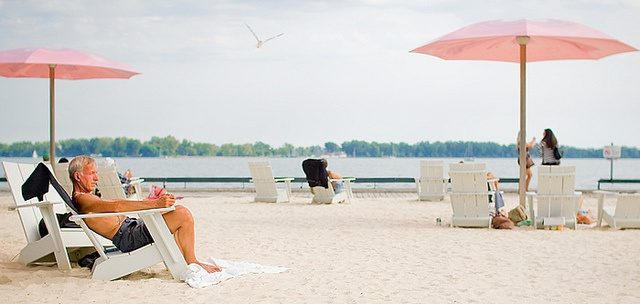Describe the objects in this image and their specific colors. I can see chair in lightgray, black, and tan tones, umbrella in lightgray, lightpink, pink, and red tones, people in lightgray, salmon, black, brown, and red tones, umbrella in lightgray, lightpink, pink, and salmon tones, and chair in lightgray, tan, and darkgray tones in this image. 